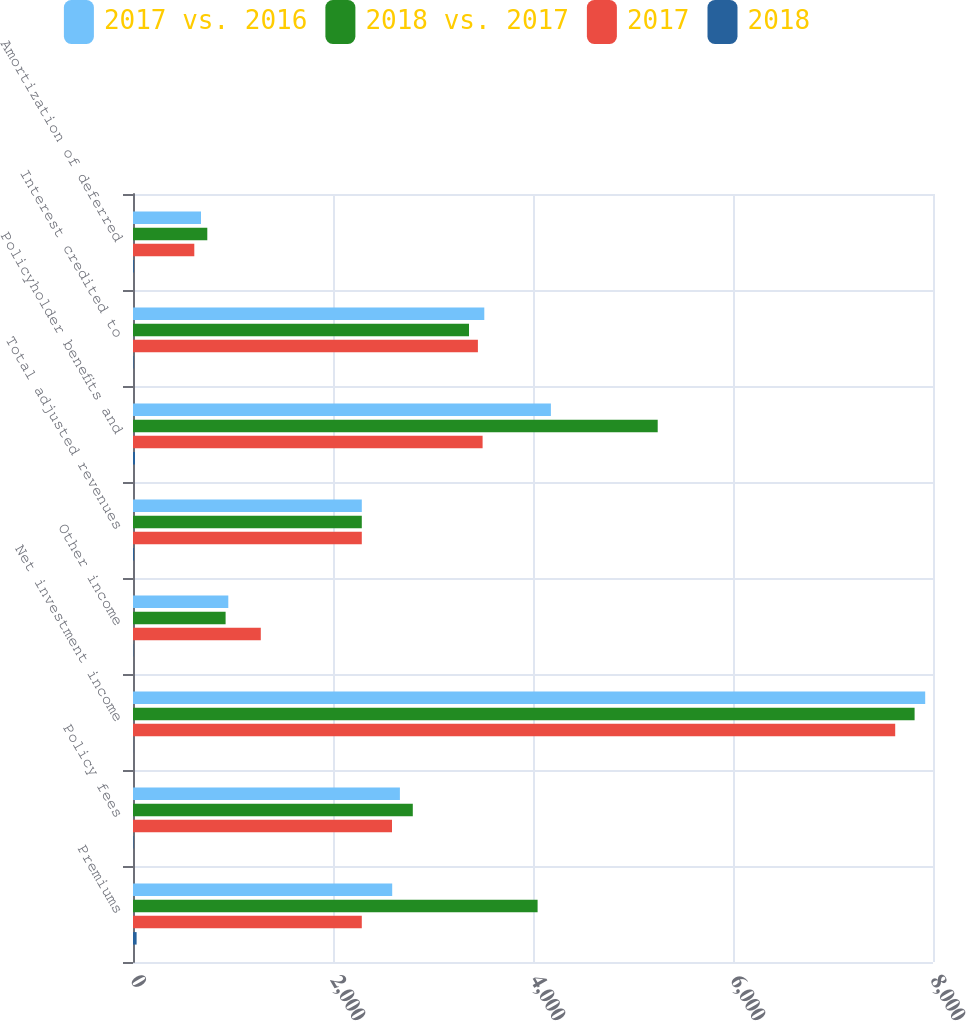<chart> <loc_0><loc_0><loc_500><loc_500><stacked_bar_chart><ecel><fcel>Premiums<fcel>Policy fees<fcel>Net investment income<fcel>Other income<fcel>Total adjusted revenues<fcel>Policyholder benefits and<fcel>Interest credited to<fcel>Amortization of deferred<nl><fcel>2017 vs. 2016<fcel>2592<fcel>2669<fcel>7922<fcel>953<fcel>2288<fcel>4179<fcel>3513<fcel>680<nl><fcel>2018 vs. 2017<fcel>4046<fcel>2798<fcel>7816<fcel>926<fcel>2288<fcel>5247<fcel>3360<fcel>743<nl><fcel>2017<fcel>2288<fcel>2590<fcel>7622<fcel>1278<fcel>2288<fcel>3496<fcel>3449<fcel>613<nl><fcel>2018<fcel>36<fcel>5<fcel>1<fcel>3<fcel>9<fcel>20<fcel>5<fcel>8<nl></chart> 